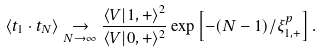<formula> <loc_0><loc_0><loc_500><loc_500>\langle { t } _ { 1 } \cdot { t } _ { N } \rangle \underset { N \to \infty } { \to } \frac { \langle V | { 1 , + } \rangle ^ { 2 } } { \langle V | { 0 , + } \rangle ^ { 2 } } \exp \left [ { - ( N - 1 ) / \xi _ { 1 , + } ^ { p } } \right ] .</formula> 